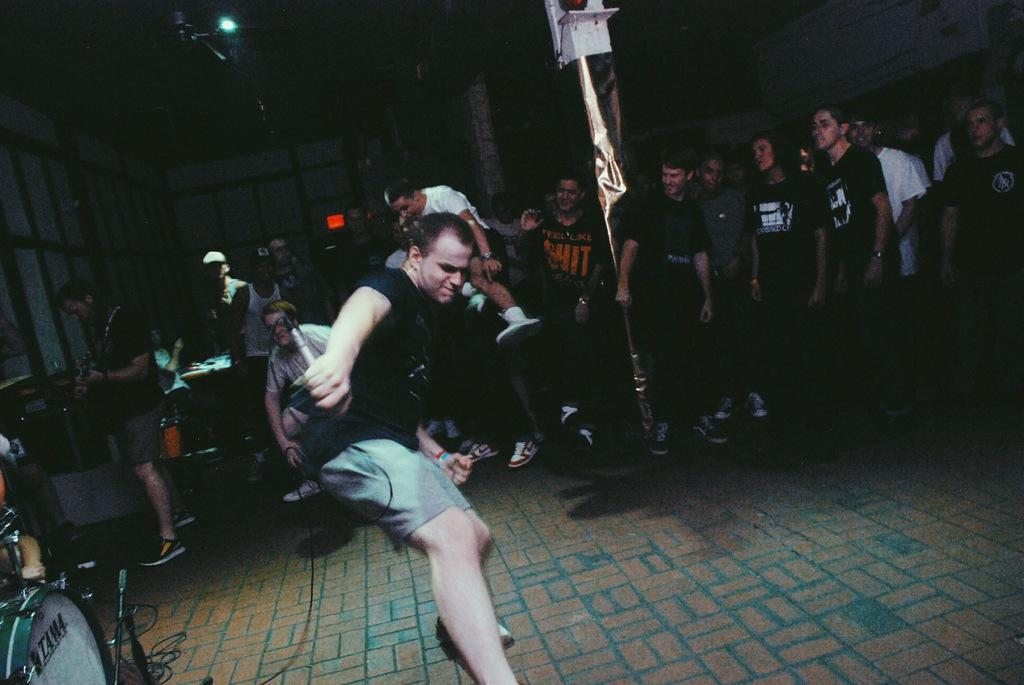What is the main subject of the image? There is a person dancing in the center of the image. Are there any other people in the image? Yes, there are many people standing behind the dancing person. What object can be seen on the left side of the image? There is a drum on the left side of the image. What can be seen at the top of the image? There is a light visible at the top of the image. How many goldfish are swimming in the drum in the image? There are no goldfish present in the image; the drum is an instrument and not a container for fish. 